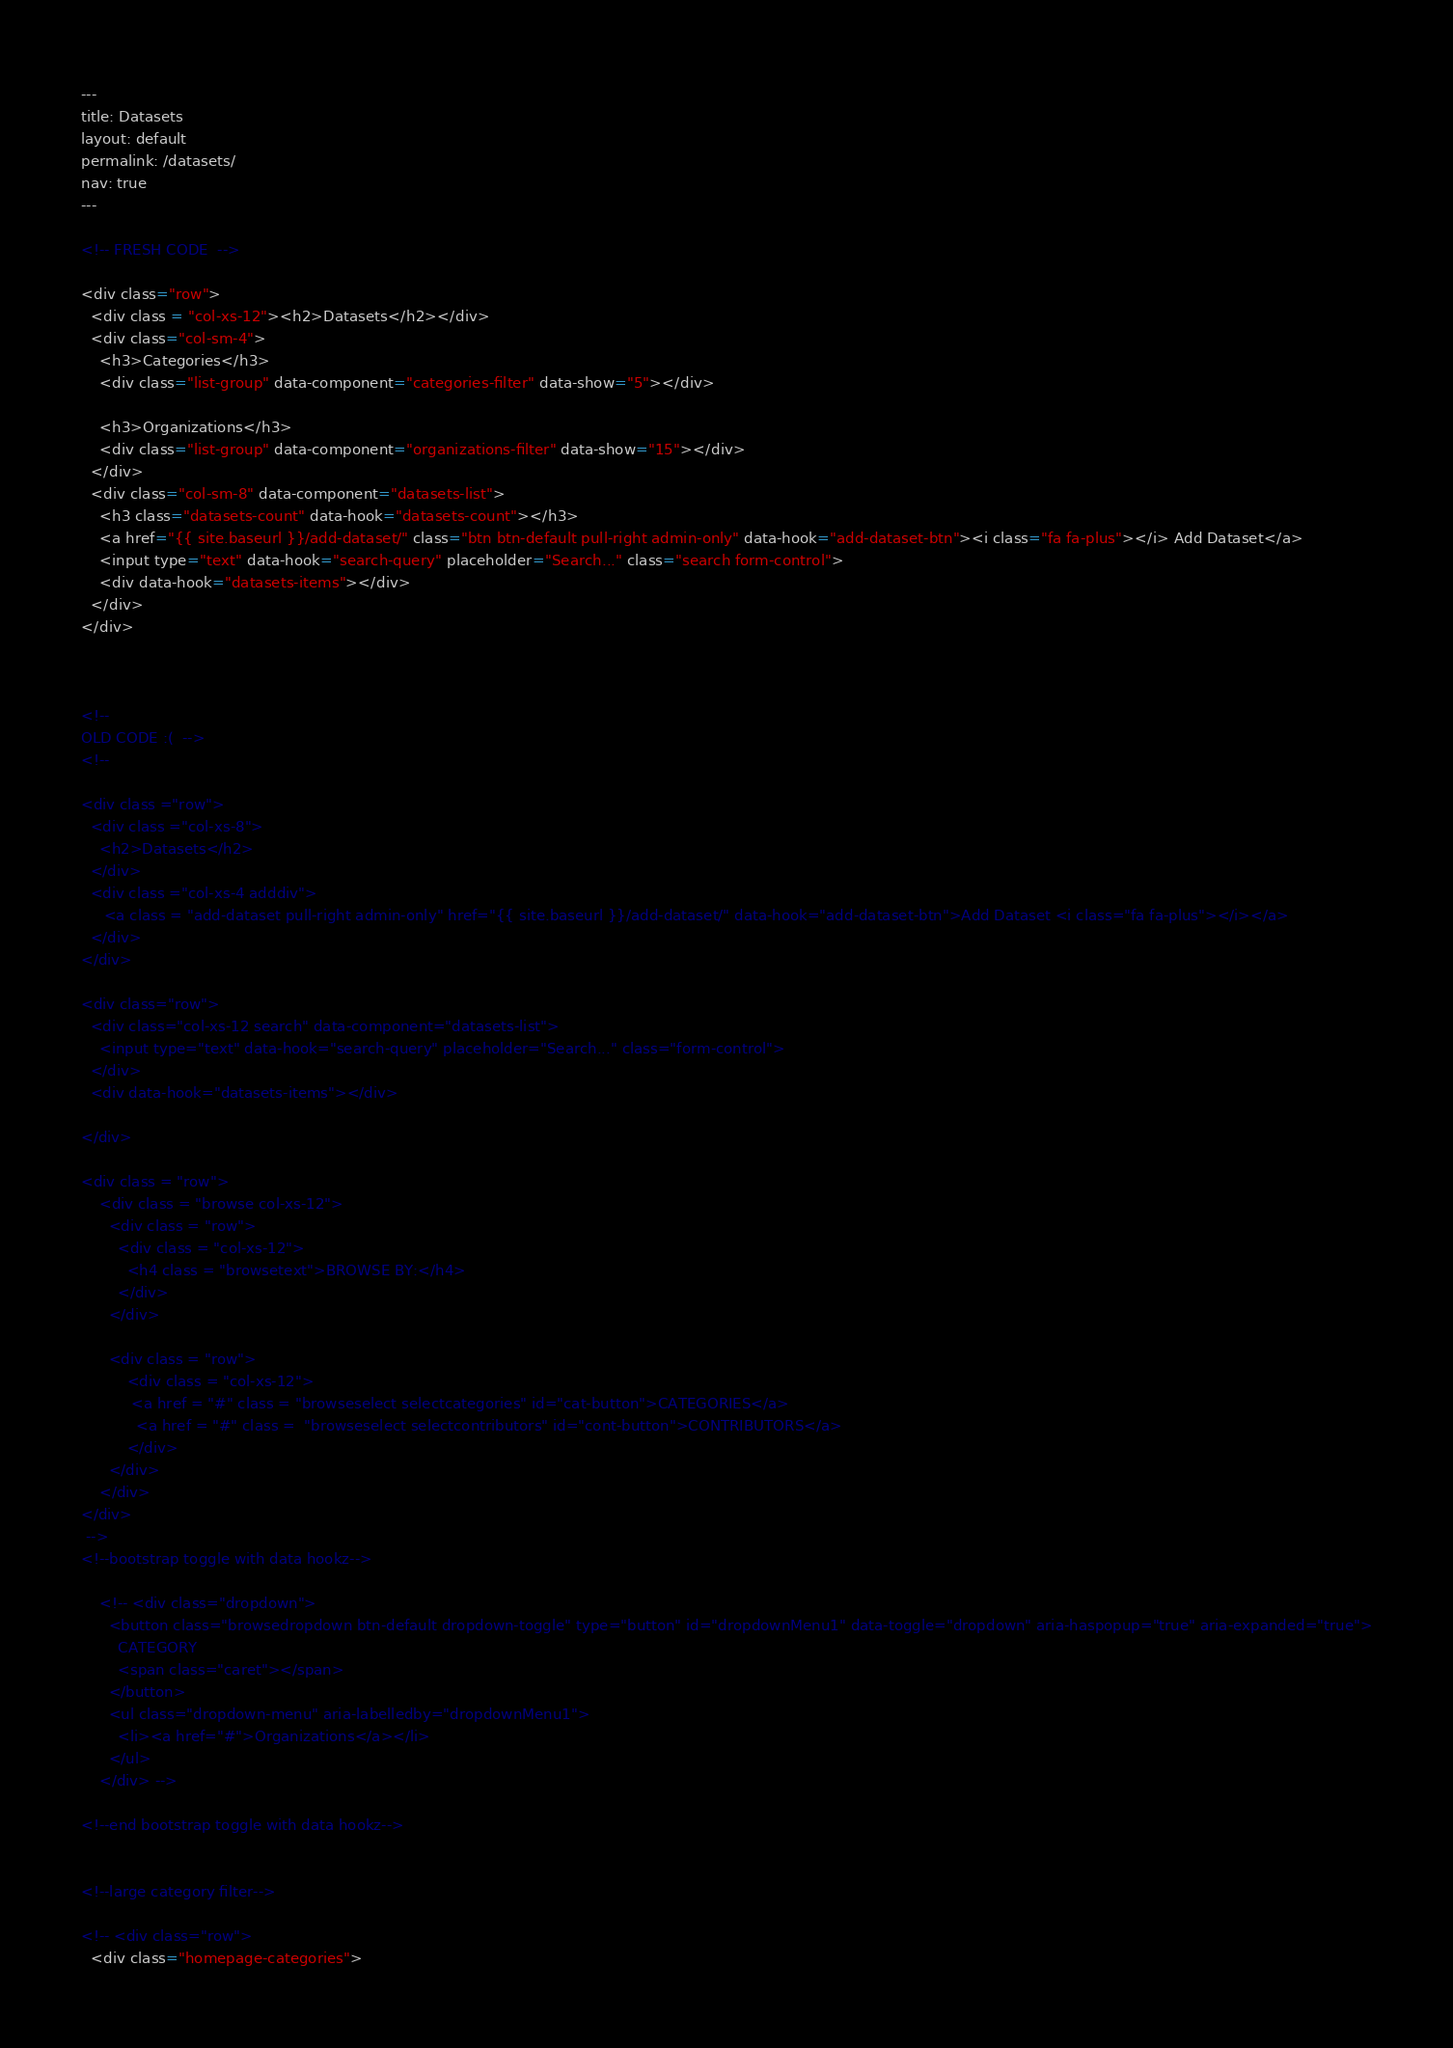Convert code to text. <code><loc_0><loc_0><loc_500><loc_500><_HTML_>---
title: Datasets
layout: default
permalink: /datasets/
nav: true
---

<!-- FRESH CODE  -->

<div class="row">
  <div class = "col-xs-12"><h2>Datasets</h2></div>
  <div class="col-sm-4">
    <h3>Categories</h3>
    <div class="list-group" data-component="categories-filter" data-show="5"></div>

    <h3>Organizations</h3>
    <div class="list-group" data-component="organizations-filter" data-show="15"></div>
  </div>
  <div class="col-sm-8" data-component="datasets-list">
    <h3 class="datasets-count" data-hook="datasets-count"></h3>
    <a href="{{ site.baseurl }}/add-dataset/" class="btn btn-default pull-right admin-only" data-hook="add-dataset-btn"><i class="fa fa-plus"></i> Add Dataset</a>
    <input type="text" data-hook="search-query" placeholder="Search..." class="search form-control">
    <div data-hook="datasets-items"></div>
  </div>
</div>



<!-- 
OLD CODE :(  -->
<!-- 

<div class ="row">
  <div class ="col-xs-8">
    <h2>Datasets</h2>
  </div>
  <div class ="col-xs-4 adddiv">
     <a class = "add-dataset pull-right admin-only" href="{{ site.baseurl }}/add-dataset/" data-hook="add-dataset-btn">Add Dataset <i class="fa fa-plus"></i></a>
  </div>
</div>

<div class="row">
  <div class="col-xs-12 search" data-component="datasets-list">
    <input type="text" data-hook="search-query" placeholder="Search..." class="form-control">
  </div>
  <div data-hook="datasets-items"></div>

</div>

<div class = "row">
    <div class = "browse col-xs-12">
      <div class = "row">
        <div class = "col-xs-12">
          <h4 class = "browsetext">BROWSE BY:</h4>
        </div>
      </div>

      <div class = "row">
          <div class = "col-xs-12">
           <a href = "#" class = "browseselect selectcategories" id="cat-button">CATEGORIES</a>
            <a href = "#" class =  "browseselect selectcontributors" id="cont-button">CONTRIBUTORS</a>
          </div>
      </div>
    </div>
</div>
 -->
<!--bootstrap toggle with data hookz-->

    <!-- <div class="dropdown">
      <button class="browsedropdown btn-default dropdown-toggle" type="button" id="dropdownMenu1" data-toggle="dropdown" aria-haspopup="true" aria-expanded="true">
        CATEGORY
        <span class="caret"></span>
      </button>
      <ul class="dropdown-menu" aria-labelledby="dropdownMenu1">
        <li><a href="#">Organizations</a></li>
      </ul>
    </div> -->

<!--end bootstrap toggle with data hookz-->


<!--large category filter-->

<!-- <div class="row">
  <div class="homepage-categories"></code> 